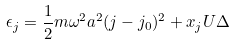Convert formula to latex. <formula><loc_0><loc_0><loc_500><loc_500>\epsilon _ { j } = \frac { 1 } { 2 } m \omega ^ { 2 } a ^ { 2 } ( j - j _ { 0 } ) ^ { 2 } + x _ { j } U \Delta</formula> 